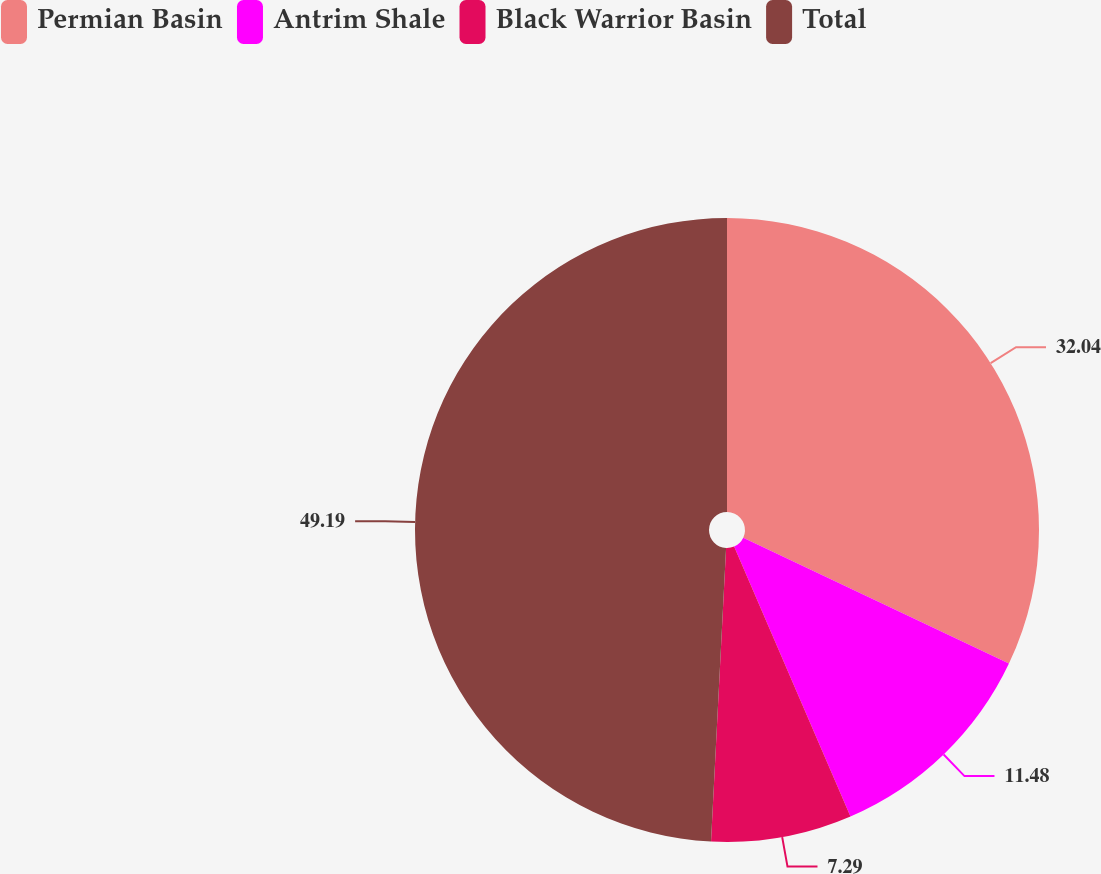<chart> <loc_0><loc_0><loc_500><loc_500><pie_chart><fcel>Permian Basin<fcel>Antrim Shale<fcel>Black Warrior Basin<fcel>Total<nl><fcel>32.04%<fcel>11.48%<fcel>7.29%<fcel>49.18%<nl></chart> 